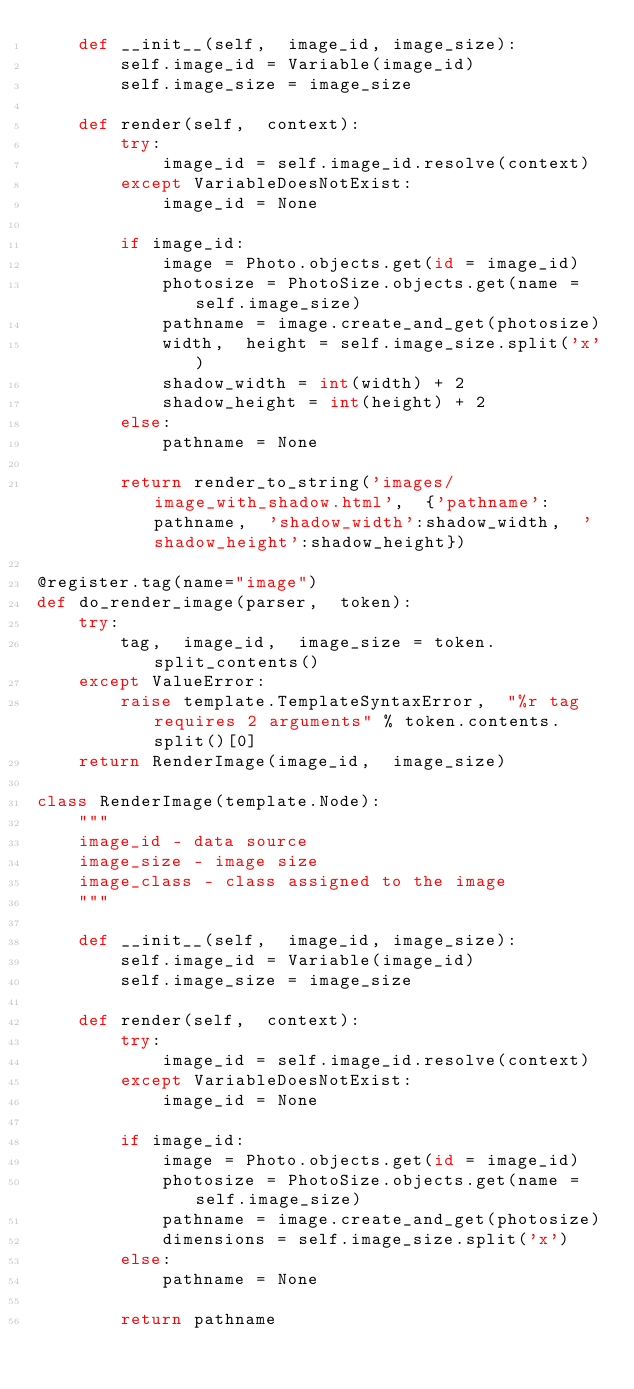Convert code to text. <code><loc_0><loc_0><loc_500><loc_500><_Python_>    def __init__(self,  image_id, image_size):
        self.image_id = Variable(image_id)
        self.image_size = image_size

    def render(self,  context):
        try:
            image_id = self.image_id.resolve(context)
        except VariableDoesNotExist:
            image_id = None
            
        if image_id:
            image = Photo.objects.get(id = image_id)
            photosize = PhotoSize.objects.get(name = self.image_size)
            pathname = image.create_and_get(photosize)
            width,  height = self.image_size.split('x')
            shadow_width = int(width) + 2
            shadow_height = int(height) + 2
        else:
            pathname = None
            
        return render_to_string('images/image_with_shadow.html',  {'pathname':pathname,  'shadow_width':shadow_width,  'shadow_height':shadow_height})
        
@register.tag(name="image")
def do_render_image(parser,  token):
    try:
        tag,  image_id,  image_size = token.split_contents()
    except ValueError:
        raise template.TemplateSyntaxError,  "%r tag requires 2 arguments" % token.contents.split()[0]
    return RenderImage(image_id,  image_size)

class RenderImage(template.Node):
    """
    image_id - data source
    image_size - image size
    image_class - class assigned to the image
    """

    def __init__(self,  image_id, image_size):
        self.image_id = Variable(image_id)
        self.image_size = image_size

    def render(self,  context):
        try:
            image_id = self.image_id.resolve(context)
        except VariableDoesNotExist:
            image_id = None
            
        if image_id:
            image = Photo.objects.get(id = image_id)
            photosize = PhotoSize.objects.get(name = self.image_size)
            pathname = image.create_and_get(photosize)
            dimensions = self.image_size.split('x')
        else:
            pathname = None
            
        return pathname


</code> 